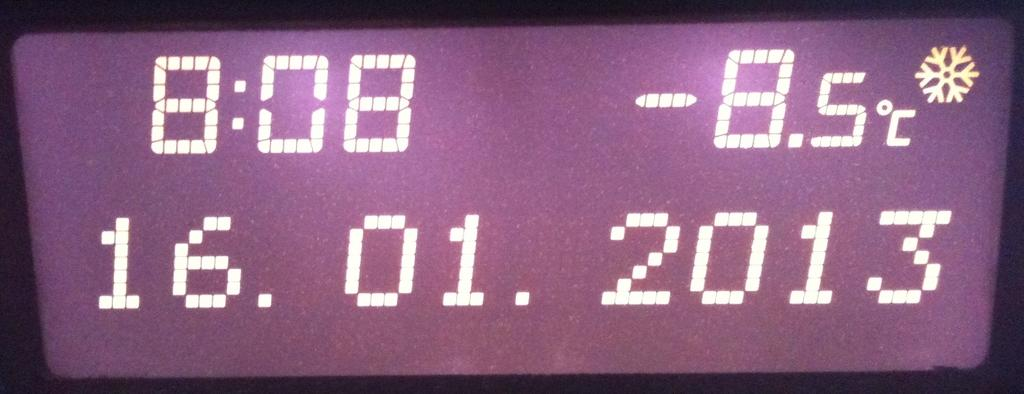<image>
Create a compact narrative representing the image presented. A screen displaying the time (8:08), the temperature (-8.5C), and the date (16.01.2013) 